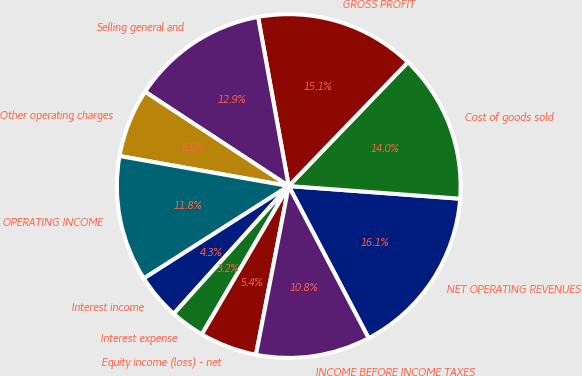Convert chart. <chart><loc_0><loc_0><loc_500><loc_500><pie_chart><fcel>NET OPERATING REVENUES<fcel>Cost of goods sold<fcel>GROSS PROFIT<fcel>Selling general and<fcel>Other operating charges<fcel>OPERATING INCOME<fcel>Interest income<fcel>Interest expense<fcel>Equity income (loss) - net<fcel>INCOME BEFORE INCOME TAXES<nl><fcel>16.13%<fcel>13.98%<fcel>15.05%<fcel>12.9%<fcel>6.45%<fcel>11.83%<fcel>4.3%<fcel>3.23%<fcel>5.38%<fcel>10.75%<nl></chart> 